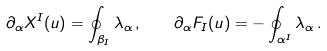Convert formula to latex. <formula><loc_0><loc_0><loc_500><loc_500>\partial _ { \alpha } X ^ { I } ( u ) = \oint _ { \beta _ { I } } \lambda _ { \alpha } \, , \quad \partial _ { \alpha } F _ { I } ( u ) = - \oint _ { \alpha ^ { I } } \lambda _ { \alpha } \, .</formula> 